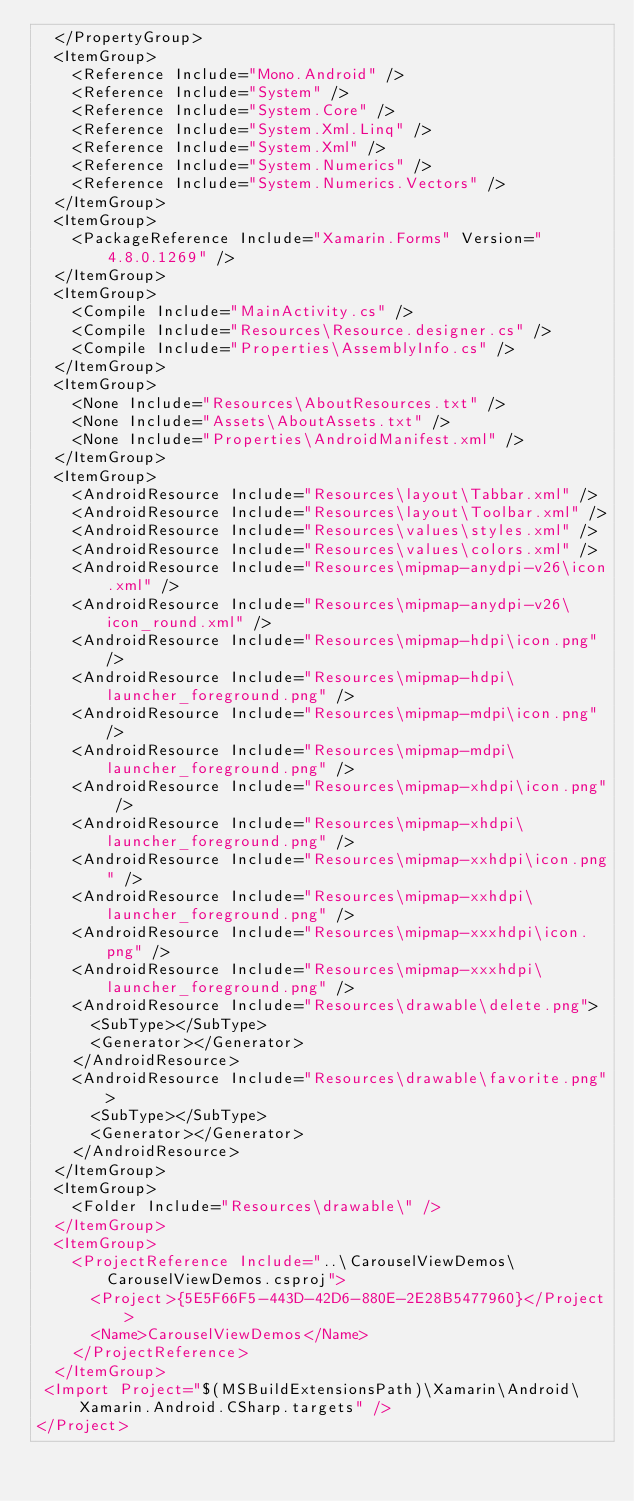<code> <loc_0><loc_0><loc_500><loc_500><_XML_>  </PropertyGroup>
  <ItemGroup>
    <Reference Include="Mono.Android" />
    <Reference Include="System" />
    <Reference Include="System.Core" />
    <Reference Include="System.Xml.Linq" />
    <Reference Include="System.Xml" />
    <Reference Include="System.Numerics" />
    <Reference Include="System.Numerics.Vectors" />
  </ItemGroup>
  <ItemGroup>
    <PackageReference Include="Xamarin.Forms" Version="4.8.0.1269" />
  </ItemGroup>
  <ItemGroup>
    <Compile Include="MainActivity.cs" />
    <Compile Include="Resources\Resource.designer.cs" />
    <Compile Include="Properties\AssemblyInfo.cs" />
  </ItemGroup>
  <ItemGroup>
    <None Include="Resources\AboutResources.txt" />
    <None Include="Assets\AboutAssets.txt" />
    <None Include="Properties\AndroidManifest.xml" />
  </ItemGroup>
  <ItemGroup>
    <AndroidResource Include="Resources\layout\Tabbar.xml" />
    <AndroidResource Include="Resources\layout\Toolbar.xml" />
    <AndroidResource Include="Resources\values\styles.xml" />
    <AndroidResource Include="Resources\values\colors.xml" />
    <AndroidResource Include="Resources\mipmap-anydpi-v26\icon.xml" />
    <AndroidResource Include="Resources\mipmap-anydpi-v26\icon_round.xml" />
    <AndroidResource Include="Resources\mipmap-hdpi\icon.png" />
    <AndroidResource Include="Resources\mipmap-hdpi\launcher_foreground.png" />
    <AndroidResource Include="Resources\mipmap-mdpi\icon.png" />
    <AndroidResource Include="Resources\mipmap-mdpi\launcher_foreground.png" />
    <AndroidResource Include="Resources\mipmap-xhdpi\icon.png" />
    <AndroidResource Include="Resources\mipmap-xhdpi\launcher_foreground.png" />
    <AndroidResource Include="Resources\mipmap-xxhdpi\icon.png" />
    <AndroidResource Include="Resources\mipmap-xxhdpi\launcher_foreground.png" />
    <AndroidResource Include="Resources\mipmap-xxxhdpi\icon.png" />
    <AndroidResource Include="Resources\mipmap-xxxhdpi\launcher_foreground.png" />
    <AndroidResource Include="Resources\drawable\delete.png">
      <SubType></SubType>
      <Generator></Generator>
    </AndroidResource>
    <AndroidResource Include="Resources\drawable\favorite.png">
      <SubType></SubType>
      <Generator></Generator>
    </AndroidResource>
  </ItemGroup>
  <ItemGroup>
    <Folder Include="Resources\drawable\" />
  </ItemGroup>
  <ItemGroup>
    <ProjectReference Include="..\CarouselViewDemos\CarouselViewDemos.csproj">
      <Project>{5E5F66F5-443D-42D6-880E-2E28B5477960}</Project>
      <Name>CarouselViewDemos</Name>
    </ProjectReference>
  </ItemGroup>
 <Import Project="$(MSBuildExtensionsPath)\Xamarin\Android\Xamarin.Android.CSharp.targets" />
</Project>
</code> 